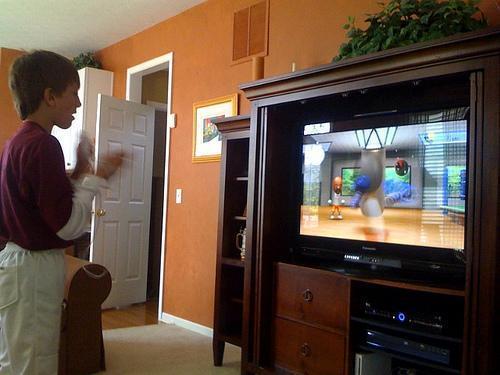How many people are there?
Give a very brief answer. 1. How many tvs are in the picture?
Give a very brief answer. 1. How many birds are pictured?
Give a very brief answer. 0. 